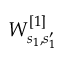Convert formula to latex. <formula><loc_0><loc_0><loc_500><loc_500>W _ { s _ { 1 } , s _ { 1 } ^ { \prime } } ^ { [ 1 ] }</formula> 